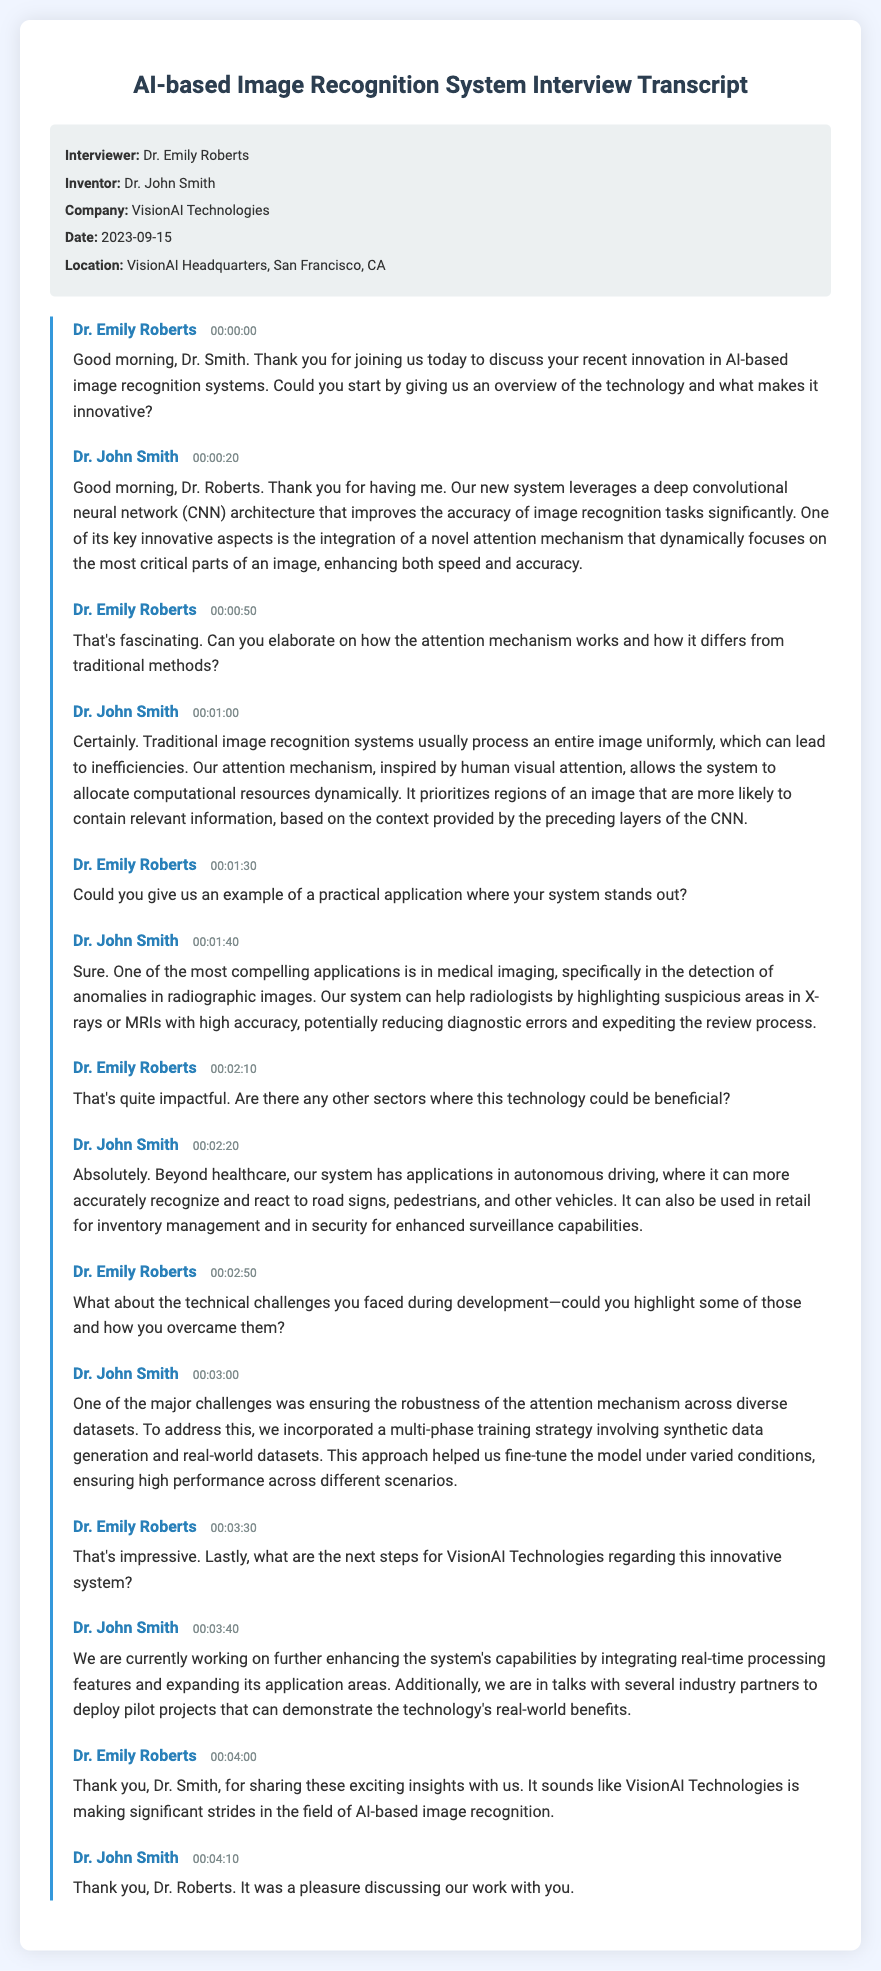What is the name of the inventor? The name of the inventor is mentioned in the document as "Dr. John Smith."
Answer: Dr. John Smith What is the date of the interview? The date of the interview is clearly stated in the document as "2023-09-15."
Answer: 2023-09-15 What novel mechanism does the system integrate? The document mentions that the system integrates a "novel attention mechanism."
Answer: novel attention mechanism In which sector can the system be applied according to Dr. Smith? Dr. Smith highlights several sectors, one of which is "healthcare."
Answer: healthcare What was one major challenge faced during development? The document states that ensuring the "robustness of the attention mechanism" was a major challenge.
Answer: robustness of the attention mechanism What training strategy was used to address challenges? The document indicates that a "multi-phase training strategy" was utilized to overcome development issues.
Answer: multi-phase training strategy Who conducted the interview? The interviewer is specified in the document as "Dr. Emily Roberts."
Answer: Dr. Emily Roberts What is the primary technology discussed in the interview? The primary technology discussed in the interview is "AI-based image recognition systems."
Answer: AI-based image recognition systems What is one practical application of the system mentioned? The document cites "detection of anomalies in radiographic images" as a practical application.
Answer: detection of anomalies in radiographic images 